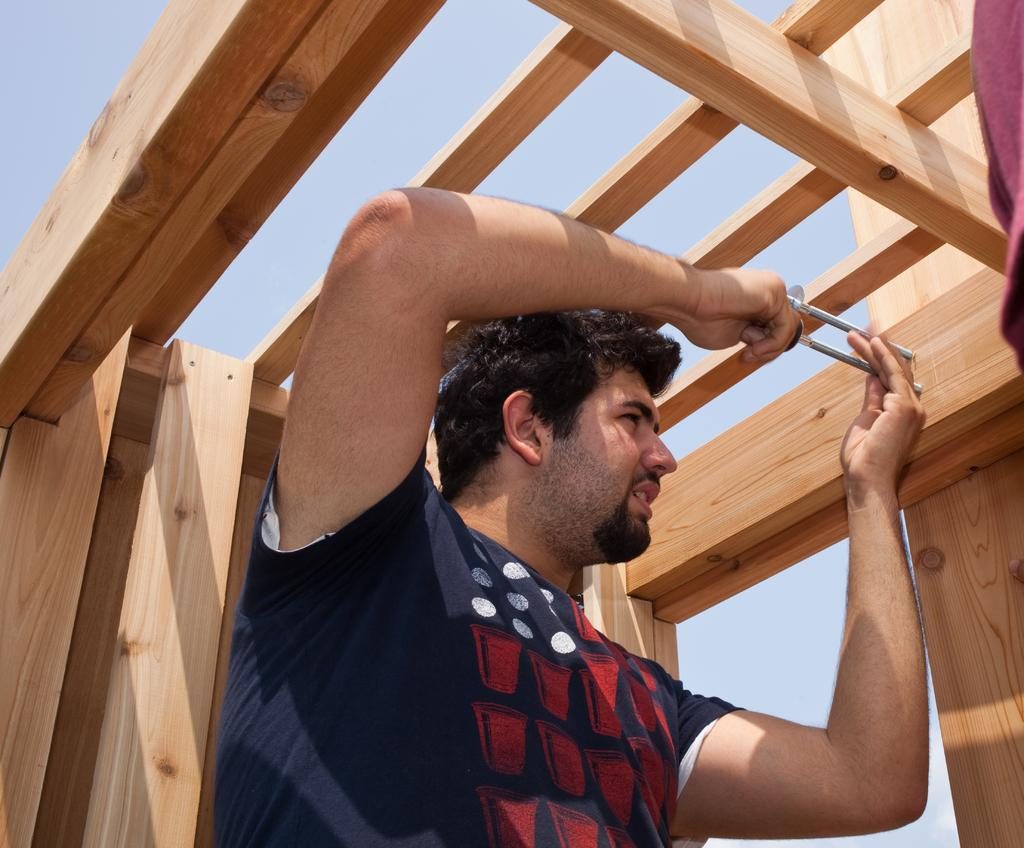What can be seen in the image? There is a person in the image. What is the person doing in the image? The person is holding a tool in his hand and fixing a screw on a wooden stick. What type of range can be seen in the background of the image? There is no range visible in the background of the image. 